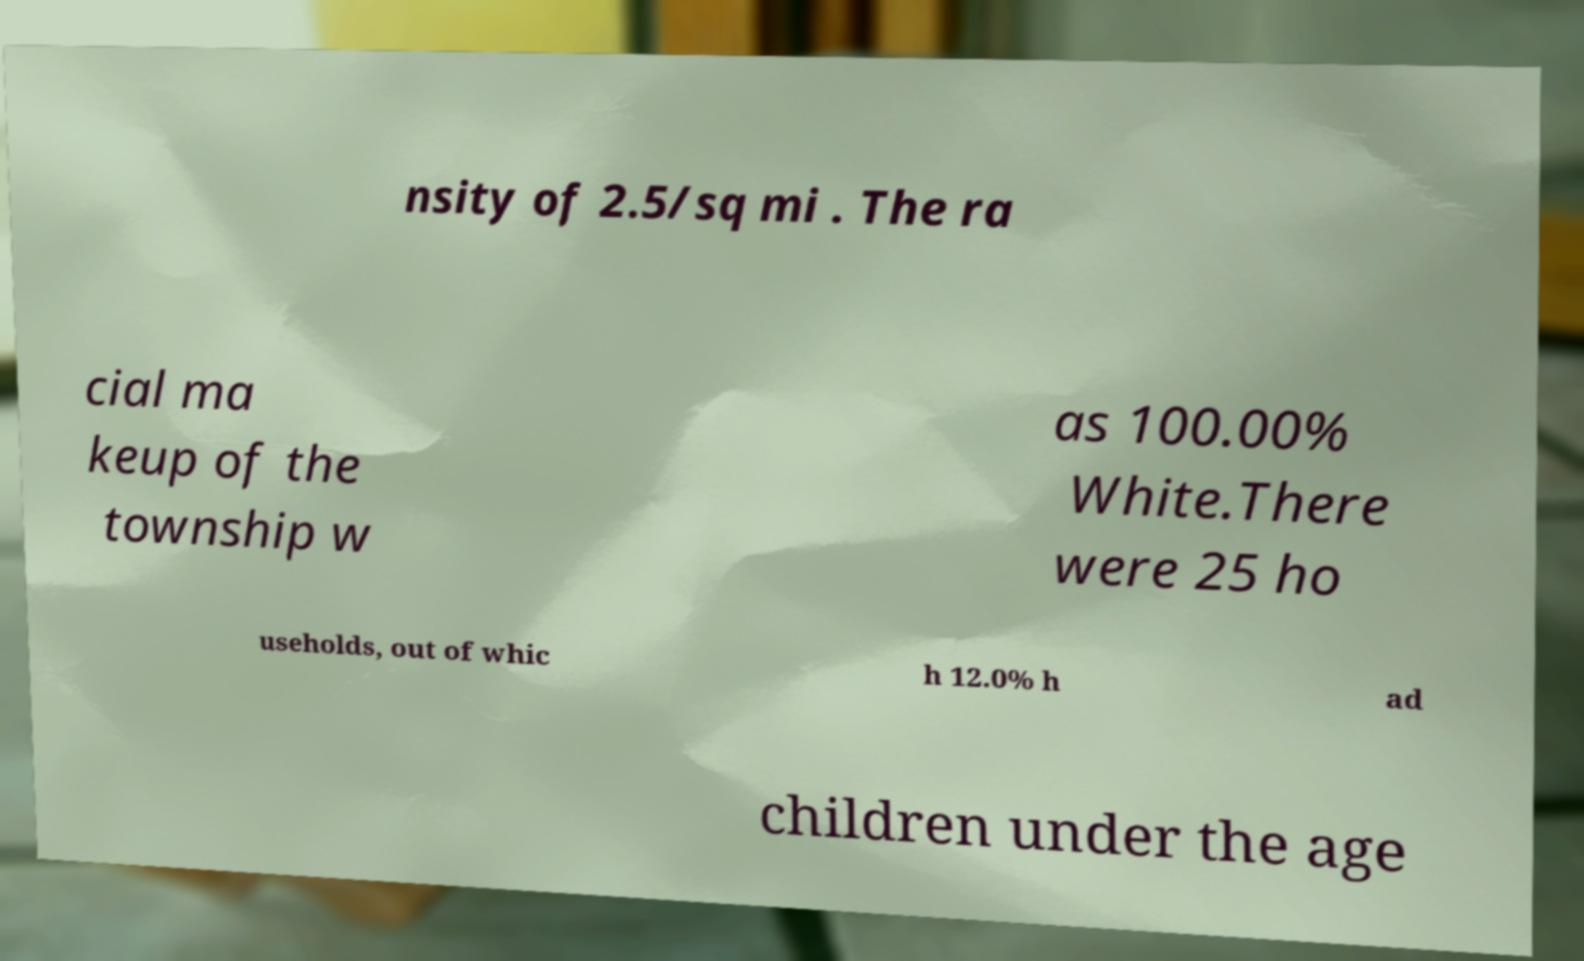I need the written content from this picture converted into text. Can you do that? nsity of 2.5/sq mi . The ra cial ma keup of the township w as 100.00% White.There were 25 ho useholds, out of whic h 12.0% h ad children under the age 